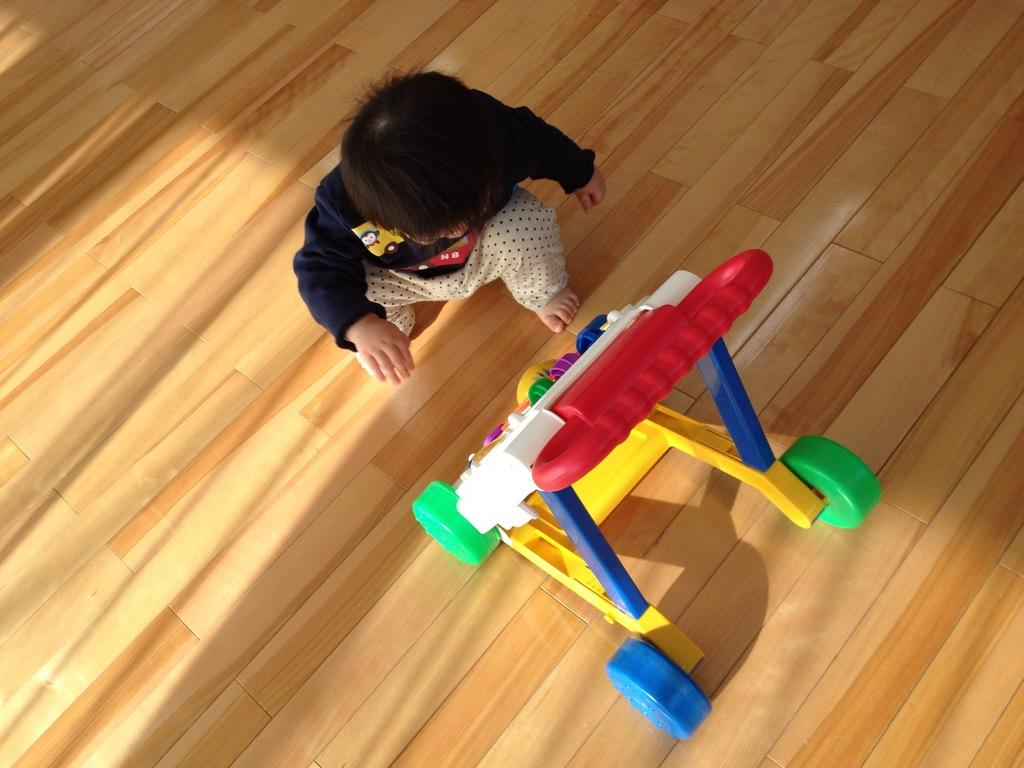What is the main subject of the image? There is a boy in the center of the image. What is the boy doing in the image? The boy is playing with a toy. Are there any other toys visible in the image? Yes, there is another toy in front of the boy. What type of flooring is visible in the image? The wooden floor is visible at the bottom of the image. What type of secretary is sitting behind the boy in the image? There is no secretary present in the image; it only features a boy playing with toys on a wooden floor. 